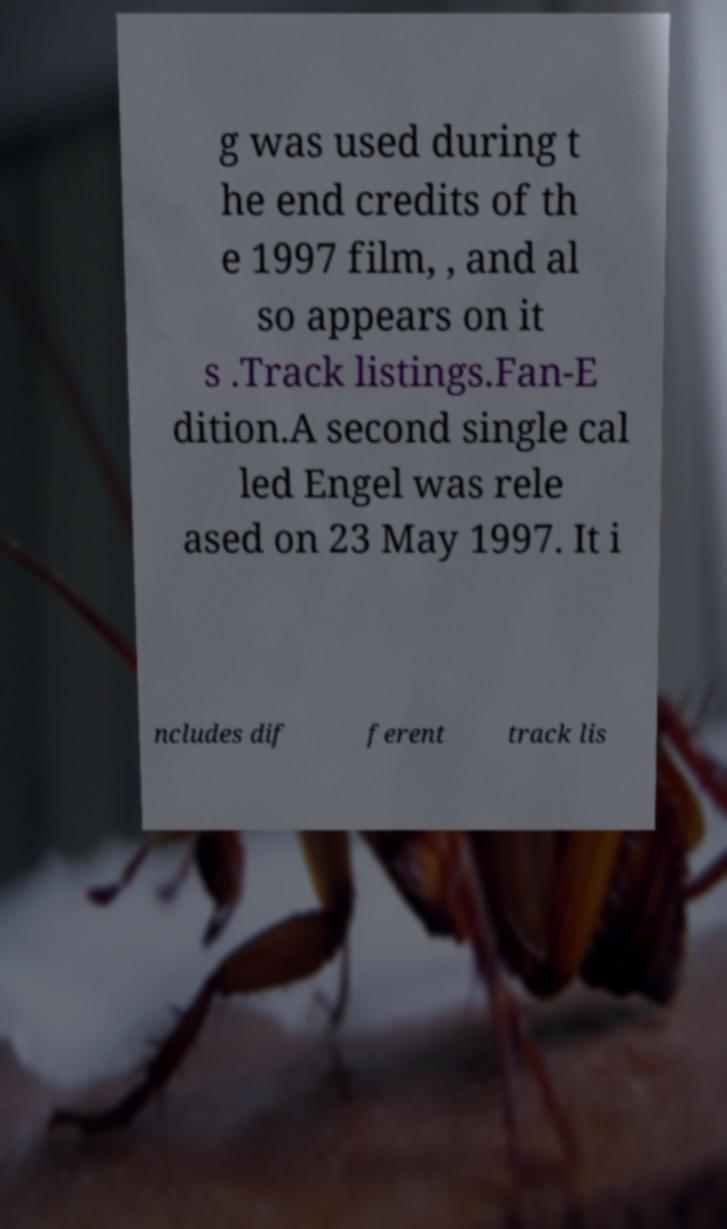Please read and relay the text visible in this image. What does it say? g was used during t he end credits of th e 1997 film, , and al so appears on it s .Track listings.Fan-E dition.A second single cal led Engel was rele ased on 23 May 1997. It i ncludes dif ferent track lis 